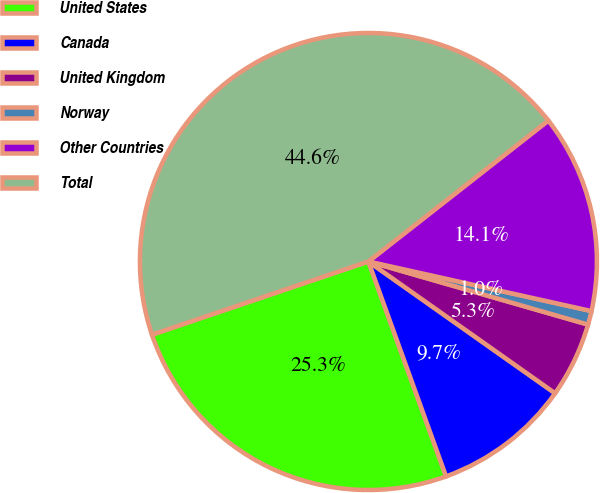<chart> <loc_0><loc_0><loc_500><loc_500><pie_chart><fcel>United States<fcel>Canada<fcel>United Kingdom<fcel>Norway<fcel>Other Countries<fcel>Total<nl><fcel>25.33%<fcel>9.7%<fcel>5.33%<fcel>0.97%<fcel>14.06%<fcel>44.61%<nl></chart> 